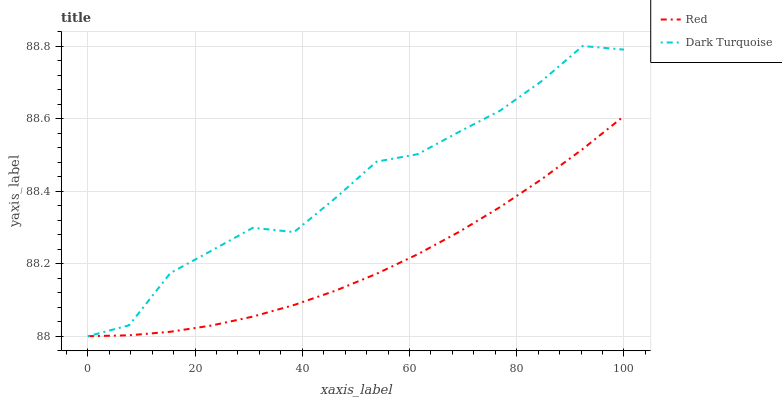Does Red have the minimum area under the curve?
Answer yes or no. Yes. Does Dark Turquoise have the maximum area under the curve?
Answer yes or no. Yes. Does Red have the maximum area under the curve?
Answer yes or no. No. Is Red the smoothest?
Answer yes or no. Yes. Is Dark Turquoise the roughest?
Answer yes or no. Yes. Is Red the roughest?
Answer yes or no. No. Does Dark Turquoise have the lowest value?
Answer yes or no. Yes. Does Red have the lowest value?
Answer yes or no. No. Does Dark Turquoise have the highest value?
Answer yes or no. Yes. Does Red have the highest value?
Answer yes or no. No. Does Red intersect Dark Turquoise?
Answer yes or no. Yes. Is Red less than Dark Turquoise?
Answer yes or no. No. Is Red greater than Dark Turquoise?
Answer yes or no. No. 